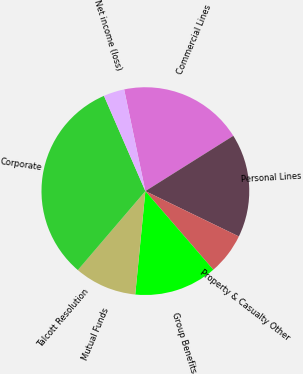Convert chart. <chart><loc_0><loc_0><loc_500><loc_500><pie_chart><fcel>Commercial Lines<fcel>Personal Lines<fcel>Property & Casualty Other<fcel>Group Benefits<fcel>Mutual Funds<fcel>Talcott Resolution<fcel>Corporate<fcel>Net income (loss)<nl><fcel>19.34%<fcel>16.12%<fcel>6.47%<fcel>12.9%<fcel>9.68%<fcel>0.03%<fcel>32.21%<fcel>3.25%<nl></chart> 